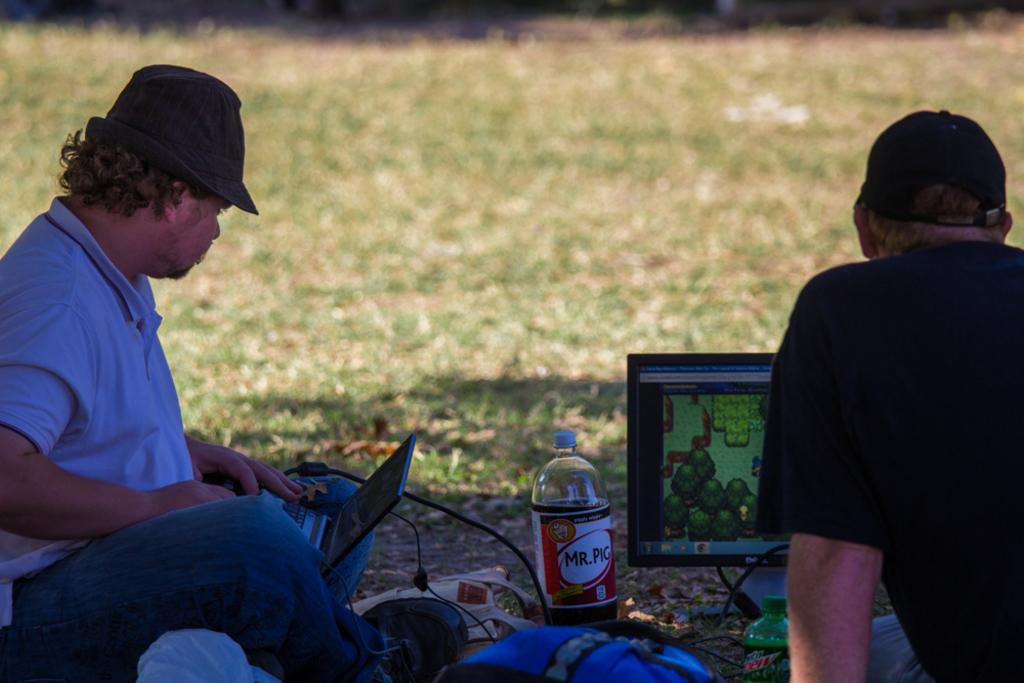How many people are in the image? There are two persons sitting on the ground in the image. What objects can be seen in the image besides the people? There is a bottle and a laptop in the image. Can you see a river flowing in the background of the image? There is no river visible in the image. Is there a gun present in the image? There is no gun present in the image. 